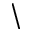<formula> <loc_0><loc_0><loc_500><loc_500>\</formula> 